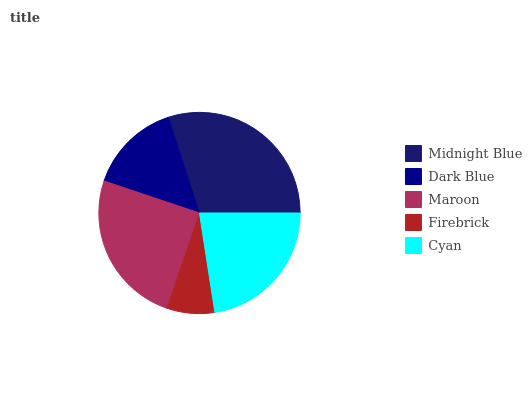Is Firebrick the minimum?
Answer yes or no. Yes. Is Midnight Blue the maximum?
Answer yes or no. Yes. Is Dark Blue the minimum?
Answer yes or no. No. Is Dark Blue the maximum?
Answer yes or no. No. Is Midnight Blue greater than Dark Blue?
Answer yes or no. Yes. Is Dark Blue less than Midnight Blue?
Answer yes or no. Yes. Is Dark Blue greater than Midnight Blue?
Answer yes or no. No. Is Midnight Blue less than Dark Blue?
Answer yes or no. No. Is Cyan the high median?
Answer yes or no. Yes. Is Cyan the low median?
Answer yes or no. Yes. Is Firebrick the high median?
Answer yes or no. No. Is Dark Blue the low median?
Answer yes or no. No. 